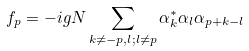Convert formula to latex. <formula><loc_0><loc_0><loc_500><loc_500>f _ { p } = - i g N \sum _ { k \neq - p , l ; l \neq p } \alpha ^ { * } _ { k } \alpha _ { l } \alpha _ { p + k - l }</formula> 